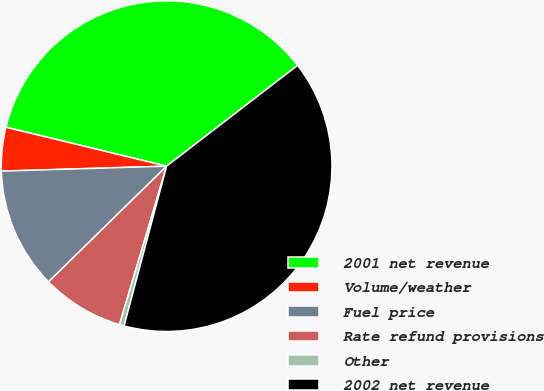Convert chart to OTSL. <chart><loc_0><loc_0><loc_500><loc_500><pie_chart><fcel>2001 net revenue<fcel>Volume/weather<fcel>Fuel price<fcel>Rate refund provisions<fcel>Other<fcel>2002 net revenue<nl><fcel>35.78%<fcel>4.26%<fcel>11.86%<fcel>8.06%<fcel>0.46%<fcel>39.58%<nl></chart> 